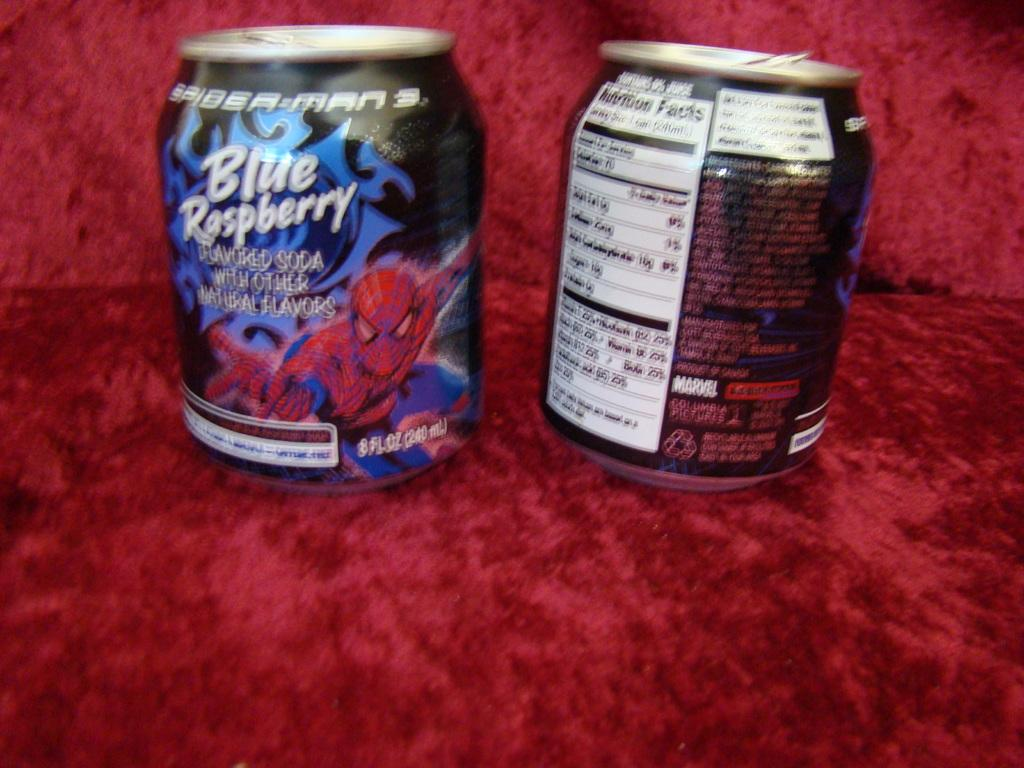Provide a one-sentence caption for the provided image. A beverage appears to be a promotional item for the movie Spider-Man 3. 